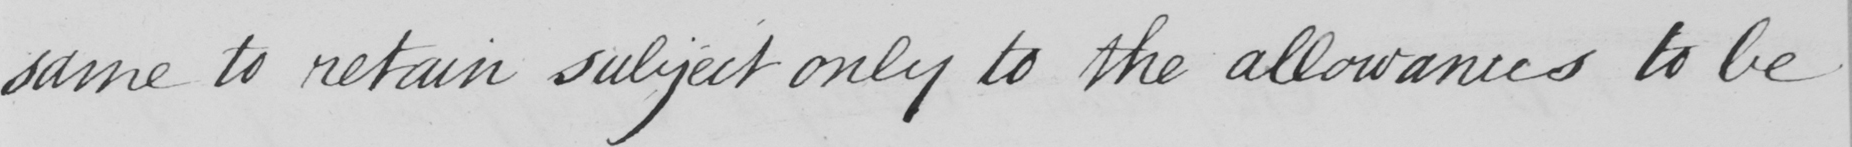Can you read and transcribe this handwriting? same to retain subject only to the allowances to be 